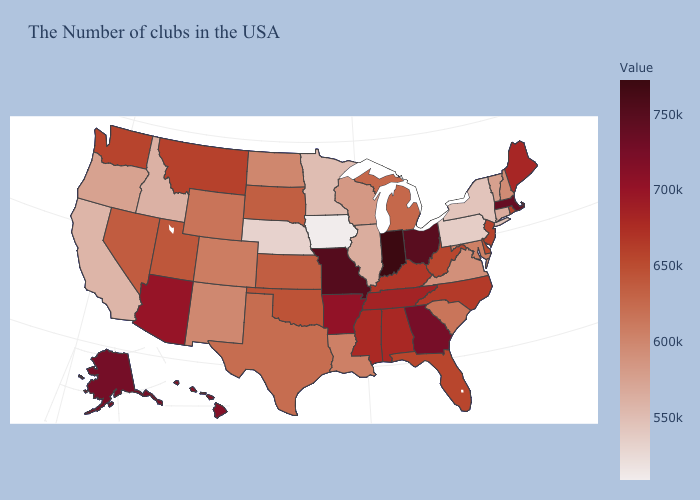Which states hav the highest value in the South?
Keep it brief. Georgia. Does the map have missing data?
Answer briefly. No. Among the states that border Colorado , does Utah have the highest value?
Write a very short answer. No. Which states have the highest value in the USA?
Be succinct. Indiana. 